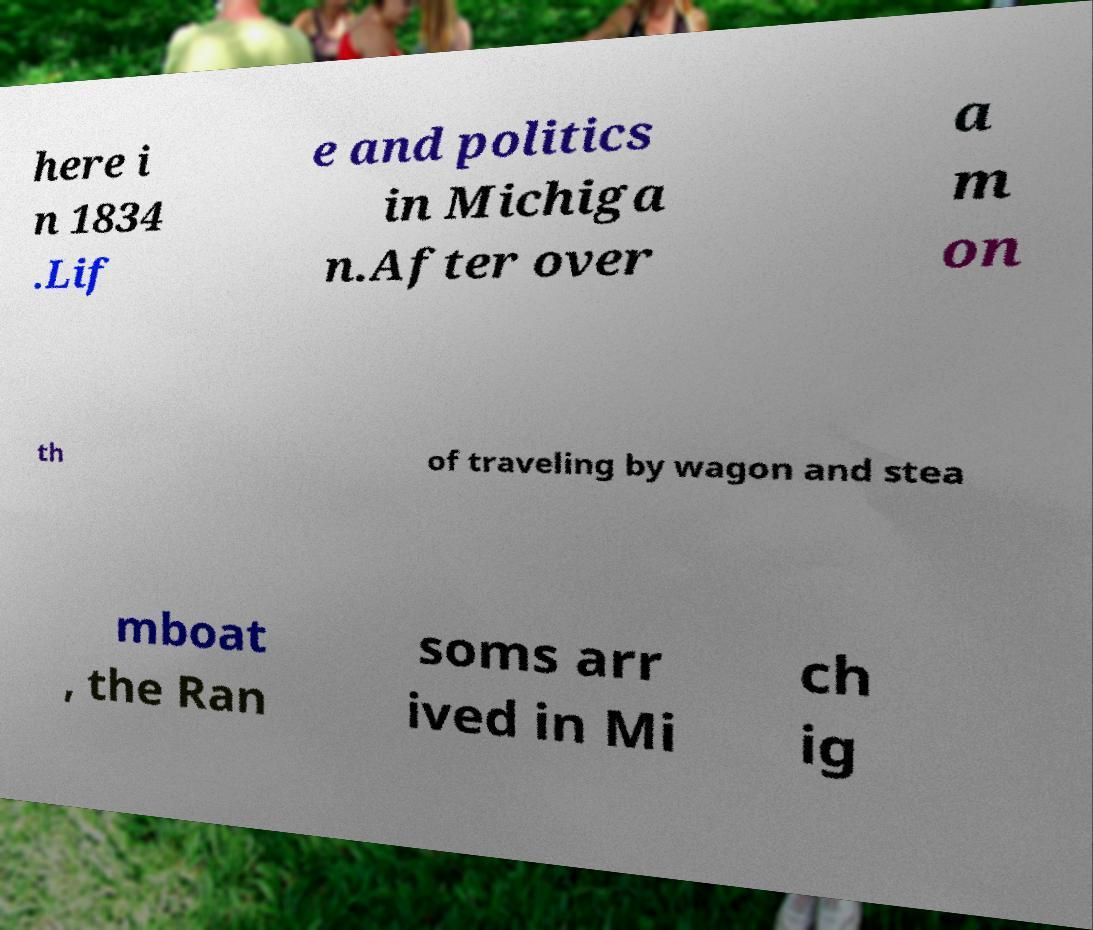Please read and relay the text visible in this image. What does it say? here i n 1834 .Lif e and politics in Michiga n.After over a m on th of traveling by wagon and stea mboat , the Ran soms arr ived in Mi ch ig 